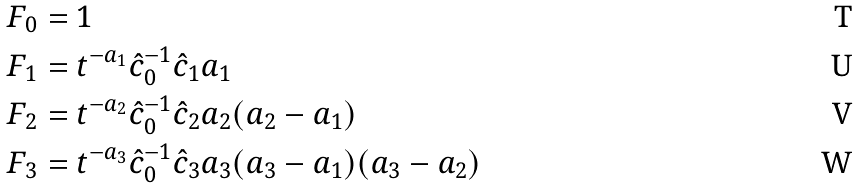<formula> <loc_0><loc_0><loc_500><loc_500>F _ { 0 } & = 1 \\ F _ { 1 } & = t ^ { - a _ { 1 } } \hat { c } _ { 0 } ^ { - 1 } \hat { c } _ { 1 } a _ { 1 } \\ F _ { 2 } & = t ^ { - a _ { 2 } } \hat { c } _ { 0 } ^ { - 1 } \hat { c } _ { 2 } a _ { 2 } ( a _ { 2 } - a _ { 1 } ) \\ F _ { 3 } & = t ^ { - a _ { 3 } } \hat { c } _ { 0 } ^ { - 1 } \hat { c } _ { 3 } a _ { 3 } ( a _ { 3 } - a _ { 1 } ) ( a _ { 3 } - a _ { 2 } )</formula> 